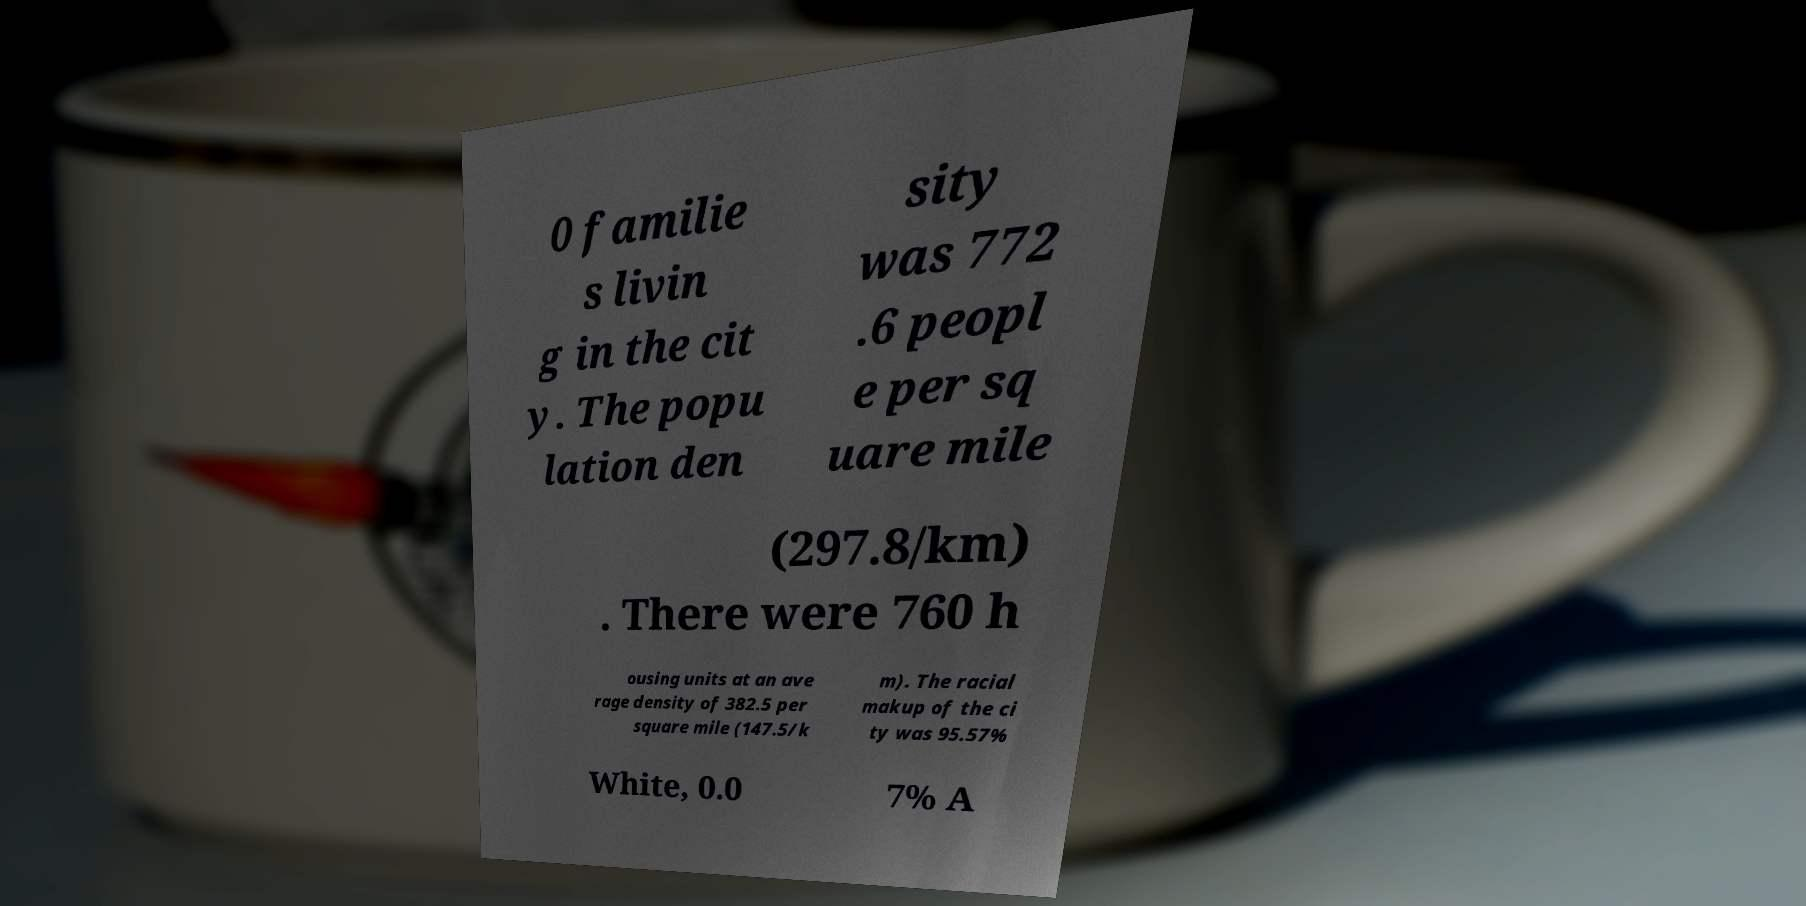Could you extract and type out the text from this image? 0 familie s livin g in the cit y. The popu lation den sity was 772 .6 peopl e per sq uare mile (297.8/km) . There were 760 h ousing units at an ave rage density of 382.5 per square mile (147.5/k m). The racial makup of the ci ty was 95.57% White, 0.0 7% A 